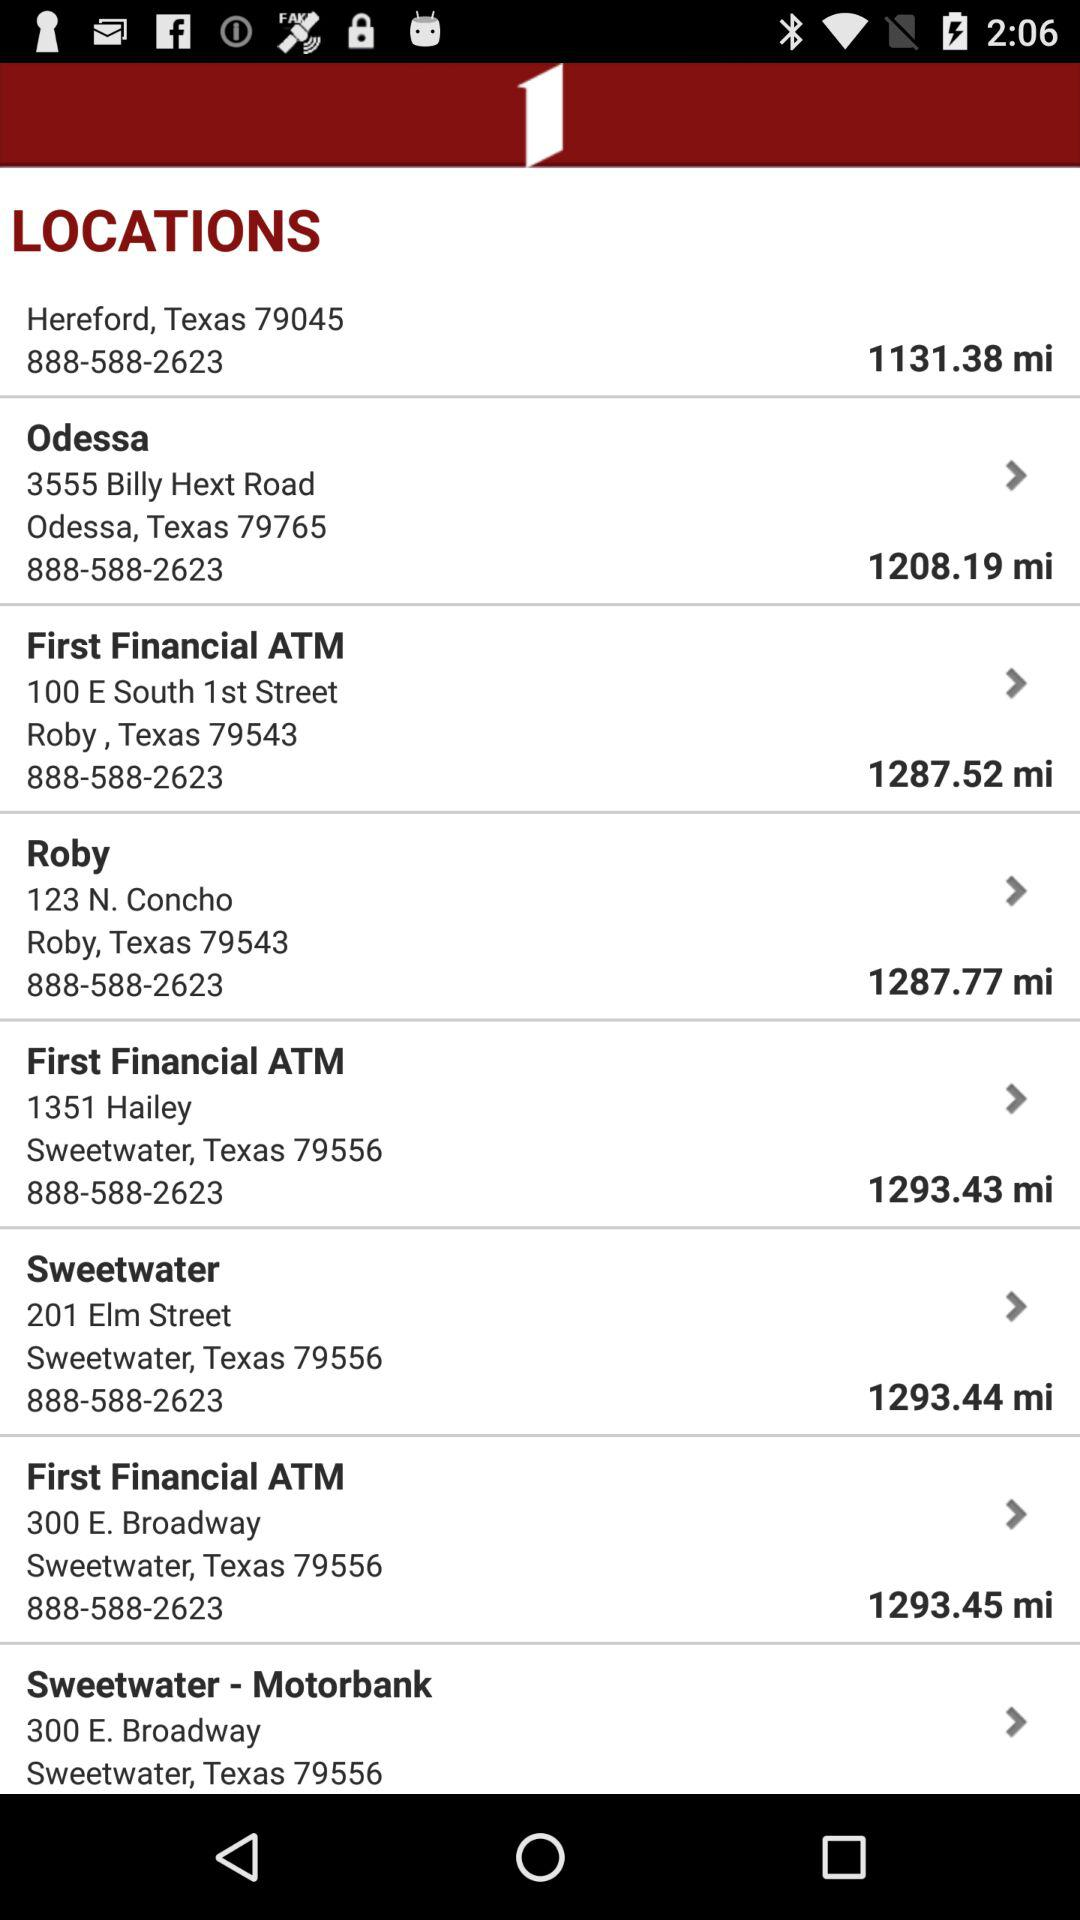What is the phone number given for all locations? The phone number given for all locations is 888-588-2623. 